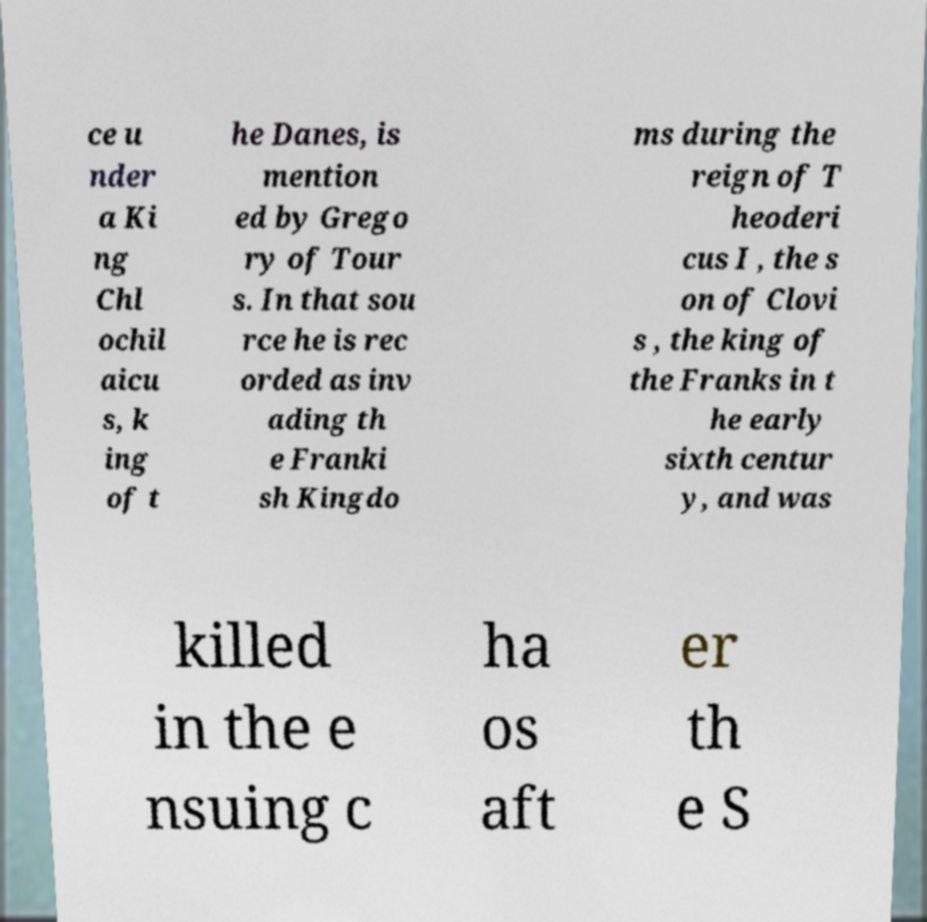Please read and relay the text visible in this image. What does it say? ce u nder a Ki ng Chl ochil aicu s, k ing of t he Danes, is mention ed by Grego ry of Tour s. In that sou rce he is rec orded as inv ading th e Franki sh Kingdo ms during the reign of T heoderi cus I , the s on of Clovi s , the king of the Franks in t he early sixth centur y, and was killed in the e nsuing c ha os aft er th e S 